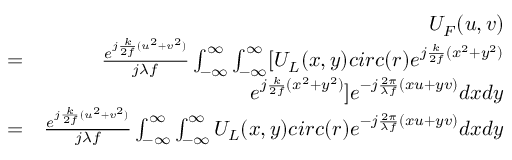Convert formula to latex. <formula><loc_0><loc_0><loc_500><loc_500>\begin{array} { r l r } & { U _ { F } ( u , v ) } \\ & { = } & { \frac { e ^ { j \frac { k } { 2 f } ( u ^ { 2 } + v ^ { 2 } ) } } { j \lambda f } \int _ { - \infty } ^ { \infty } \int _ { - \infty } ^ { \infty } [ U _ { L } ( x , y ) c i r c ( r ) e ^ { j \frac { k } { 2 f } ( x ^ { 2 } + y ^ { 2 } ) } } \\ & { e ^ { j \frac { k } { 2 f } ( x ^ { 2 } + y ^ { 2 } ) } ] e ^ { - j \frac { 2 \pi } { \lambda f } ( x u + y v ) } d x d y } \\ & { = } & { \frac { e ^ { j \frac { k } { 2 f } ( u ^ { 2 } + v ^ { 2 } ) } } { j \lambda f } \int _ { - \infty } ^ { \infty } \int _ { - \infty } ^ { \infty } U _ { L } ( x , y ) c i r c ( r ) e ^ { - j \frac { 2 \pi } { \lambda f } ( x u + y v ) } d x d y } \end{array}</formula> 